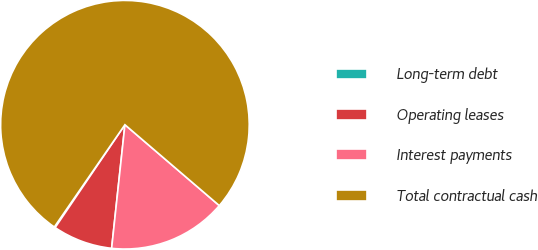Convert chart. <chart><loc_0><loc_0><loc_500><loc_500><pie_chart><fcel>Long-term debt<fcel>Operating leases<fcel>Interest payments<fcel>Total contractual cash<nl><fcel>0.13%<fcel>7.78%<fcel>15.43%<fcel>76.66%<nl></chart> 